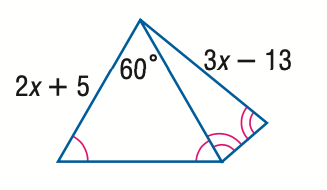Answer the mathemtical geometry problem and directly provide the correct option letter.
Question: Find x.
Choices: A: 8 B: 13 C: 18 D: 23 C 